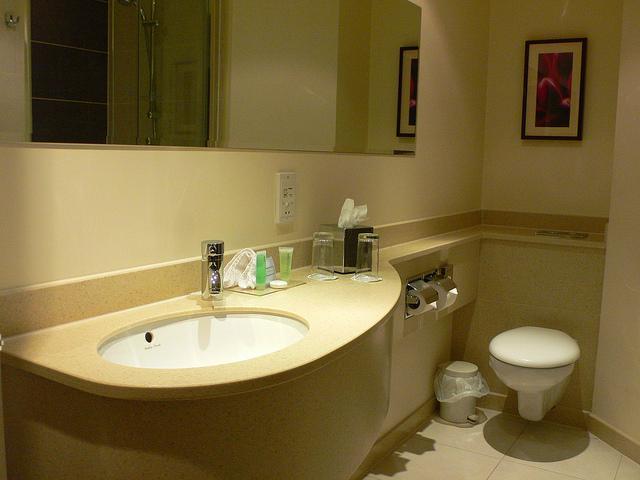What is missing from this picture?
Make your selection from the four choices given to correctly answer the question.
Options: Tissues, trash, brush, soap. Brush. 